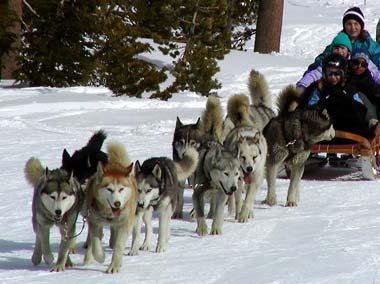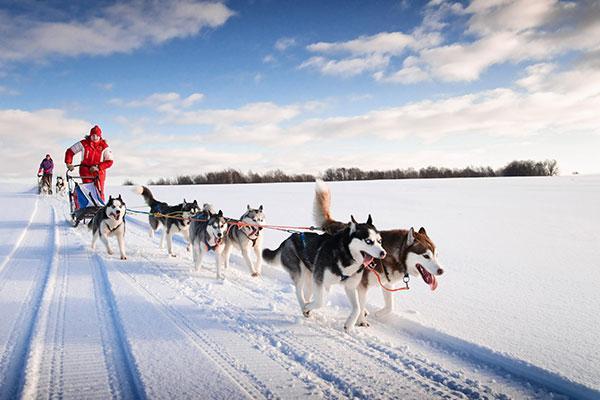The first image is the image on the left, the second image is the image on the right. For the images shown, is this caption "There is a person in a red coat in the image on the right." true? Answer yes or no. Yes. The first image is the image on the left, the second image is the image on the right. For the images shown, is this caption "The right image shows a dog sled team heading straight toward the camera." true? Answer yes or no. No. The first image is the image on the left, the second image is the image on the right. Analyze the images presented: Is the assertion "An image shows a sled dog team heading rightward and downward." valid? Answer yes or no. Yes. 